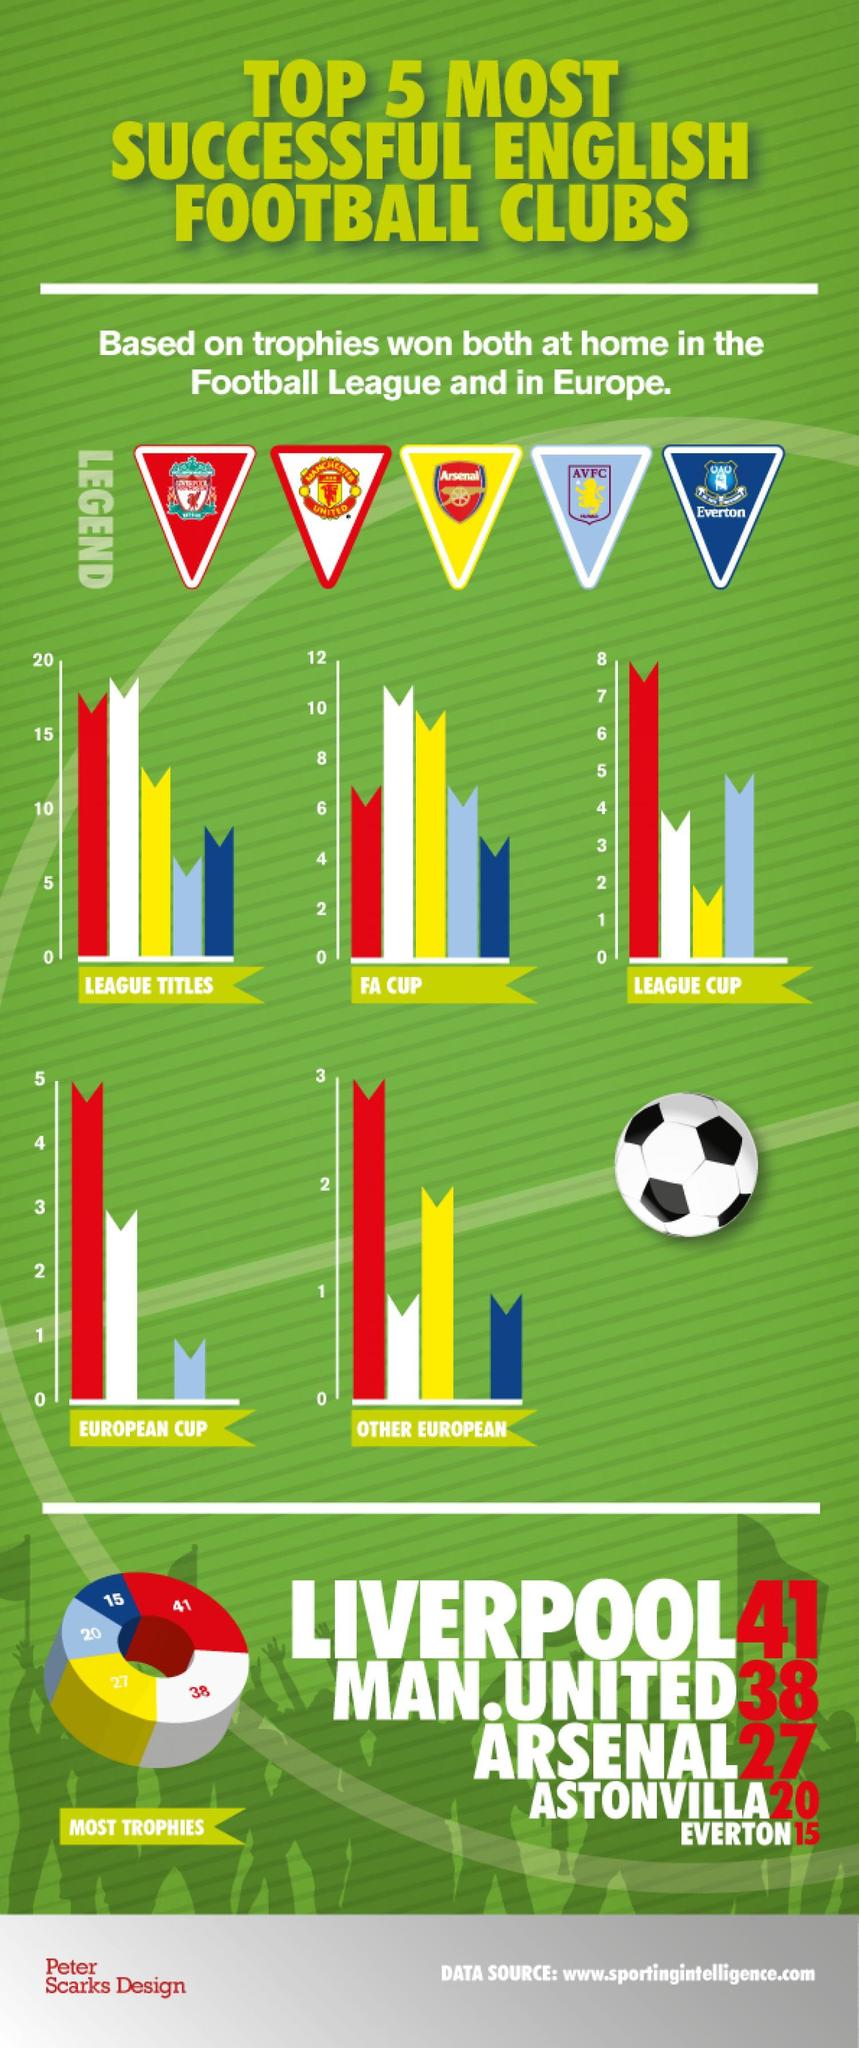Which football club has won the least number of trophies at home in the football league and in Europe?
Answer the question with a short phrase. EVERTON In which football cup, Everton FC has won the least number of trophies? FA CUP Which football club has won the highest number of trophies at home in the football league and in Europe? LIVERPOOL 